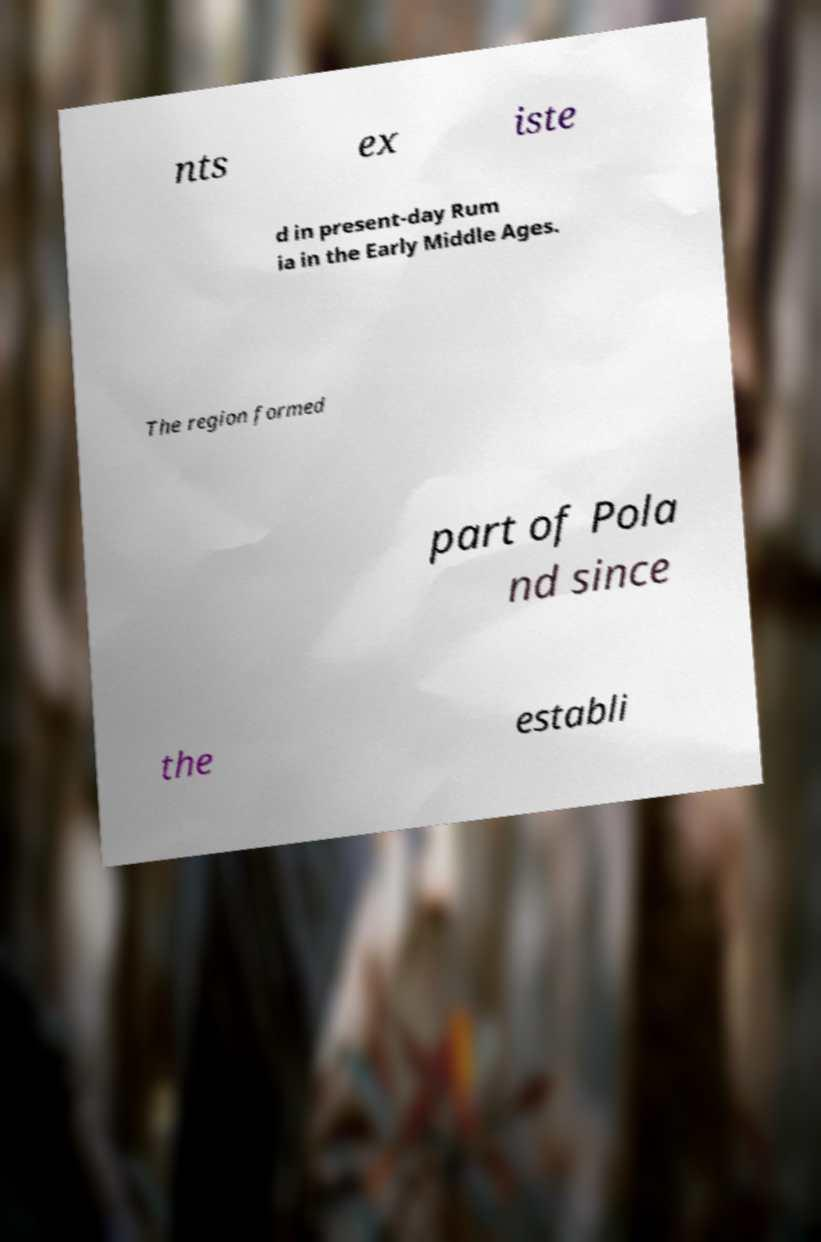Can you accurately transcribe the text from the provided image for me? nts ex iste d in present-day Rum ia in the Early Middle Ages. The region formed part of Pola nd since the establi 